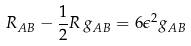Convert formula to latex. <formula><loc_0><loc_0><loc_500><loc_500>R _ { A B } - \frac { 1 } { 2 } R \, g _ { A B } = 6 \epsilon ^ { 2 } g _ { A B }</formula> 